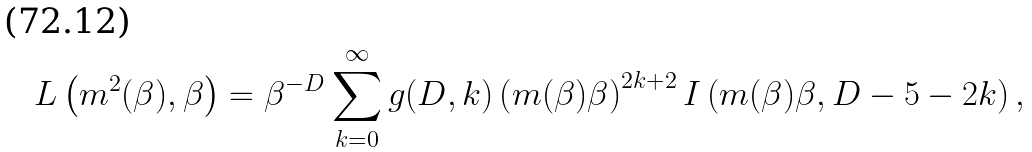Convert formula to latex. <formula><loc_0><loc_0><loc_500><loc_500>L \left ( m ^ { 2 } ( \beta ) , \beta \right ) = \beta ^ { - D } \sum _ { k = 0 } ^ { \infty } g ( D , k ) \left ( m ( \beta ) \beta \right ) ^ { 2 k + 2 } I \left ( m ( \beta ) \beta , D - 5 - 2 k \right ) ,</formula> 